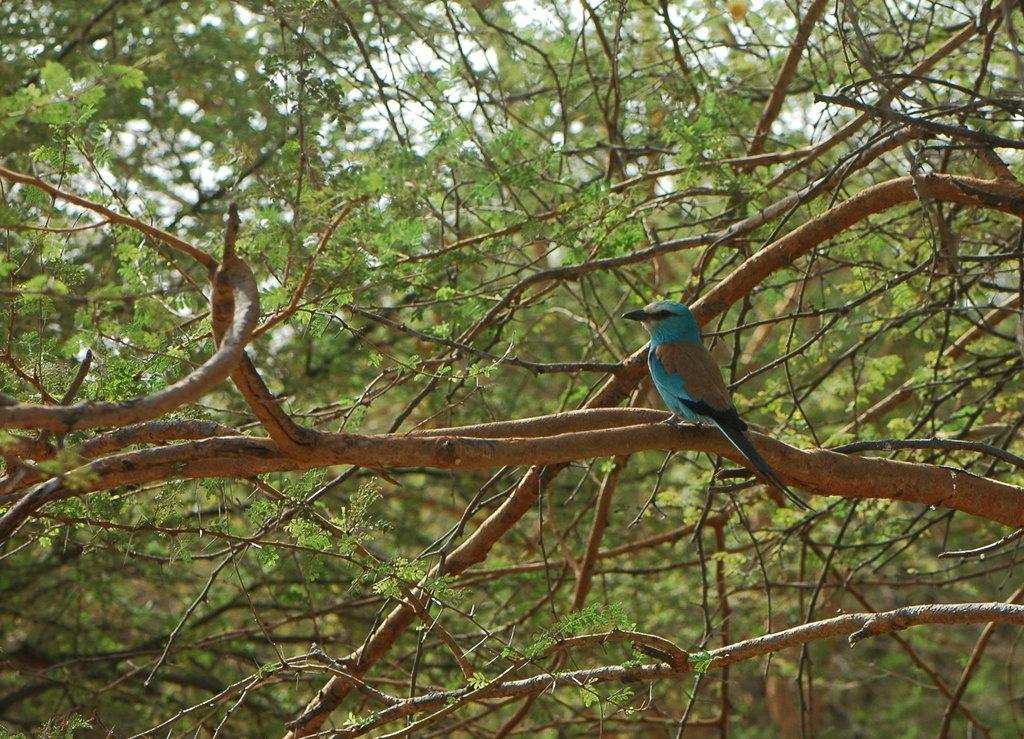What type of animal can be seen in the image? There is a bird in the image. Where is the bird located in the image? The bird is standing on a branch. What can be seen in the background of the image? There are trees with branches and leaves in the image. What type of advertisement can be seen on the bird's chin in the image? There is no advertisement present on the bird's chin in the image, as the bird does not have a chin. 